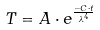Convert formula to latex. <formula><loc_0><loc_0><loc_500><loc_500>T = A \cdot e ^ { \frac { - C \cdot t } { \lambda ^ { 4 } } }</formula> 